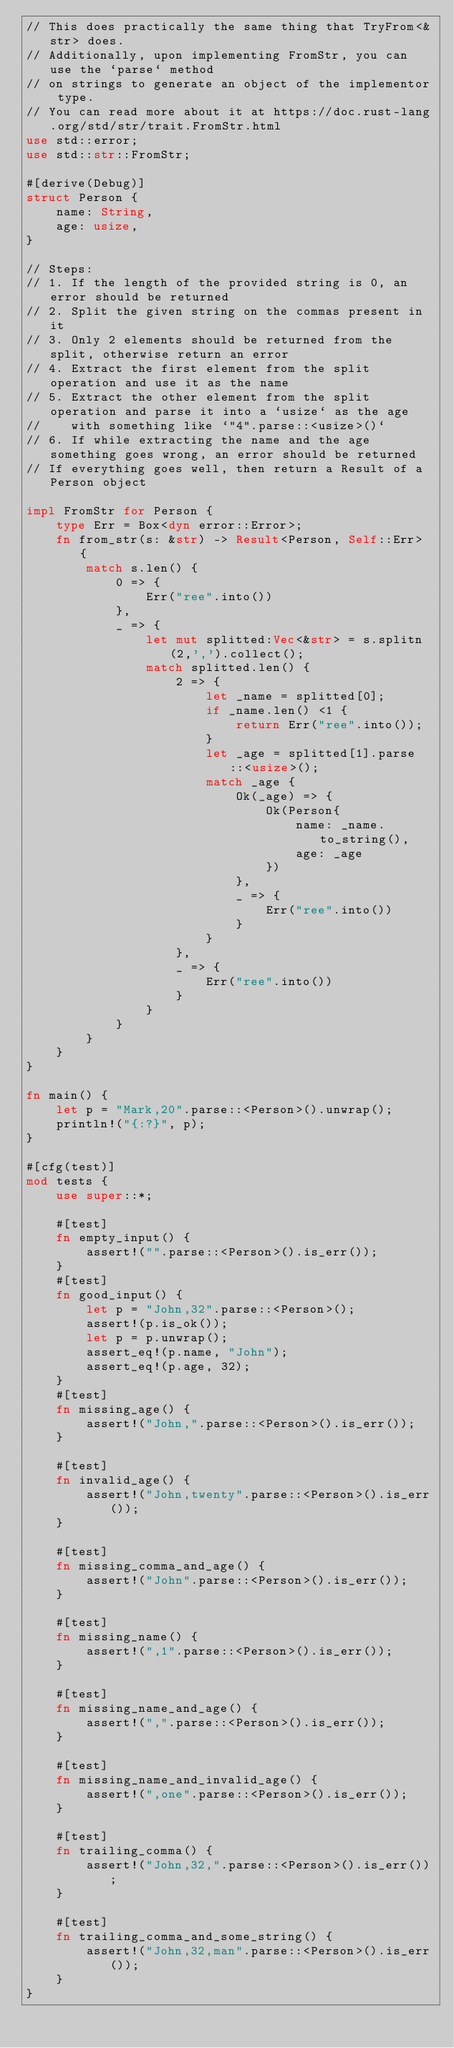<code> <loc_0><loc_0><loc_500><loc_500><_Rust_>// This does practically the same thing that TryFrom<&str> does.
// Additionally, upon implementing FromStr, you can use the `parse` method
// on strings to generate an object of the implementor type.
// You can read more about it at https://doc.rust-lang.org/std/str/trait.FromStr.html
use std::error;
use std::str::FromStr;

#[derive(Debug)]
struct Person {
    name: String,
    age: usize,
}

// Steps:
// 1. If the length of the provided string is 0, an error should be returned
// 2. Split the given string on the commas present in it
// 3. Only 2 elements should be returned from the split, otherwise return an error
// 4. Extract the first element from the split operation and use it as the name
// 5. Extract the other element from the split operation and parse it into a `usize` as the age
//    with something like `"4".parse::<usize>()`
// 6. If while extracting the name and the age something goes wrong, an error should be returned
// If everything goes well, then return a Result of a Person object

impl FromStr for Person {
    type Err = Box<dyn error::Error>;
    fn from_str(s: &str) -> Result<Person, Self::Err> {
        match s.len() {
            0 => {
                Err("ree".into())
            },
            _ => {
                let mut splitted:Vec<&str> = s.splitn(2,',').collect();
                match splitted.len() {
                    2 => {
                        let _name = splitted[0];
                        if _name.len() <1 {
                            return Err("ree".into());
                        }
                        let _age = splitted[1].parse::<usize>();
                        match _age {
                            Ok(_age) => {
                                Ok(Person{
                                    name: _name.to_string(),
                                    age: _age
                                })
                            },
                            _ => {
                                Err("ree".into())
                            }
                        }
                    },
                    _ => {
                        Err("ree".into())
                    }
                }
            }
        }
    }
}

fn main() {
    let p = "Mark,20".parse::<Person>().unwrap();
    println!("{:?}", p);
}

#[cfg(test)]
mod tests {
    use super::*;

    #[test]
    fn empty_input() {
        assert!("".parse::<Person>().is_err());
    }
    #[test]
    fn good_input() {
        let p = "John,32".parse::<Person>();
        assert!(p.is_ok());
        let p = p.unwrap();
        assert_eq!(p.name, "John");
        assert_eq!(p.age, 32);
    }
    #[test]
    fn missing_age() {
        assert!("John,".parse::<Person>().is_err());
    }

    #[test]
    fn invalid_age() {
        assert!("John,twenty".parse::<Person>().is_err());
    }

    #[test]
    fn missing_comma_and_age() {
        assert!("John".parse::<Person>().is_err());
    }

    #[test]
    fn missing_name() {
        assert!(",1".parse::<Person>().is_err());
    }

    #[test]
    fn missing_name_and_age() {
        assert!(",".parse::<Person>().is_err());
    }

    #[test]
    fn missing_name_and_invalid_age() {
        assert!(",one".parse::<Person>().is_err());
    }

    #[test]
    fn trailing_comma() {
        assert!("John,32,".parse::<Person>().is_err());
    }

    #[test]
    fn trailing_comma_and_some_string() {
        assert!("John,32,man".parse::<Person>().is_err());
    }
}
</code> 